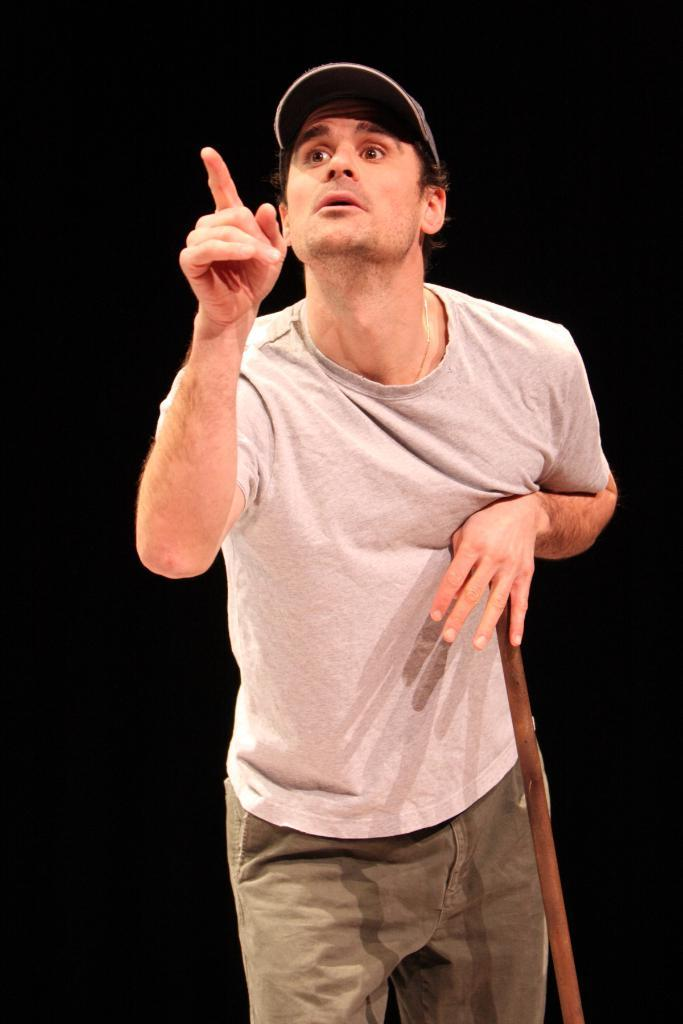What is the main subject of the image? There is a man standing in the image. What is the man holding in the image? The man is holding a stick. What type of headwear is the man wearing? The man is wearing a cap. What is the color of the background in the image? The background of the image is black in color. What type of animal can be seen drinking milk in the image? There is no animal or milk present in the image; it features a man standing with a stick and wearing a cap against a black background. 